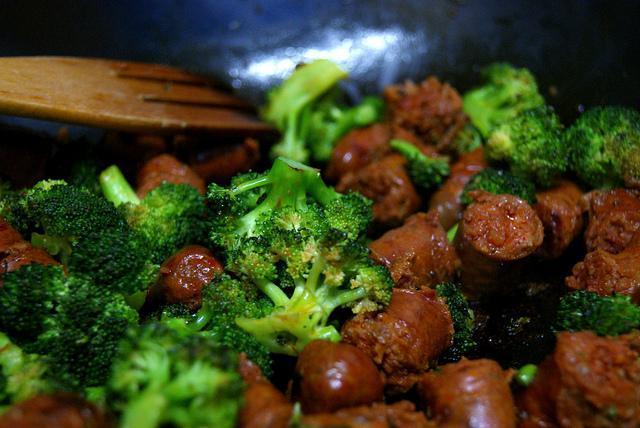How many broccolis are in the photo?
Give a very brief answer. 5. 